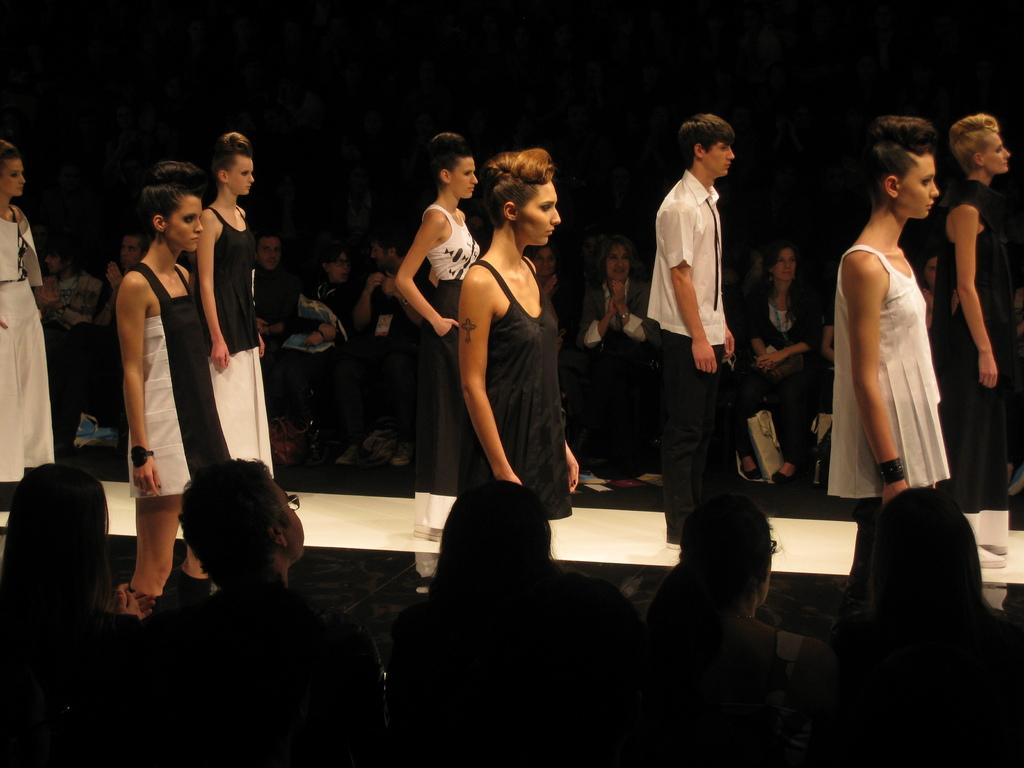What are the people in the image doing? There are people standing on a ramp and groups of people sitting. Can you describe the setting of the image? The background appears dark. What type of chain is being used by the fireman in the image? There is no fireman or chain present in the image. What type of cushion is being used by the people sitting in the image? There is no mention of cushions in the image; the people are sitting on a ramp or other surface. 